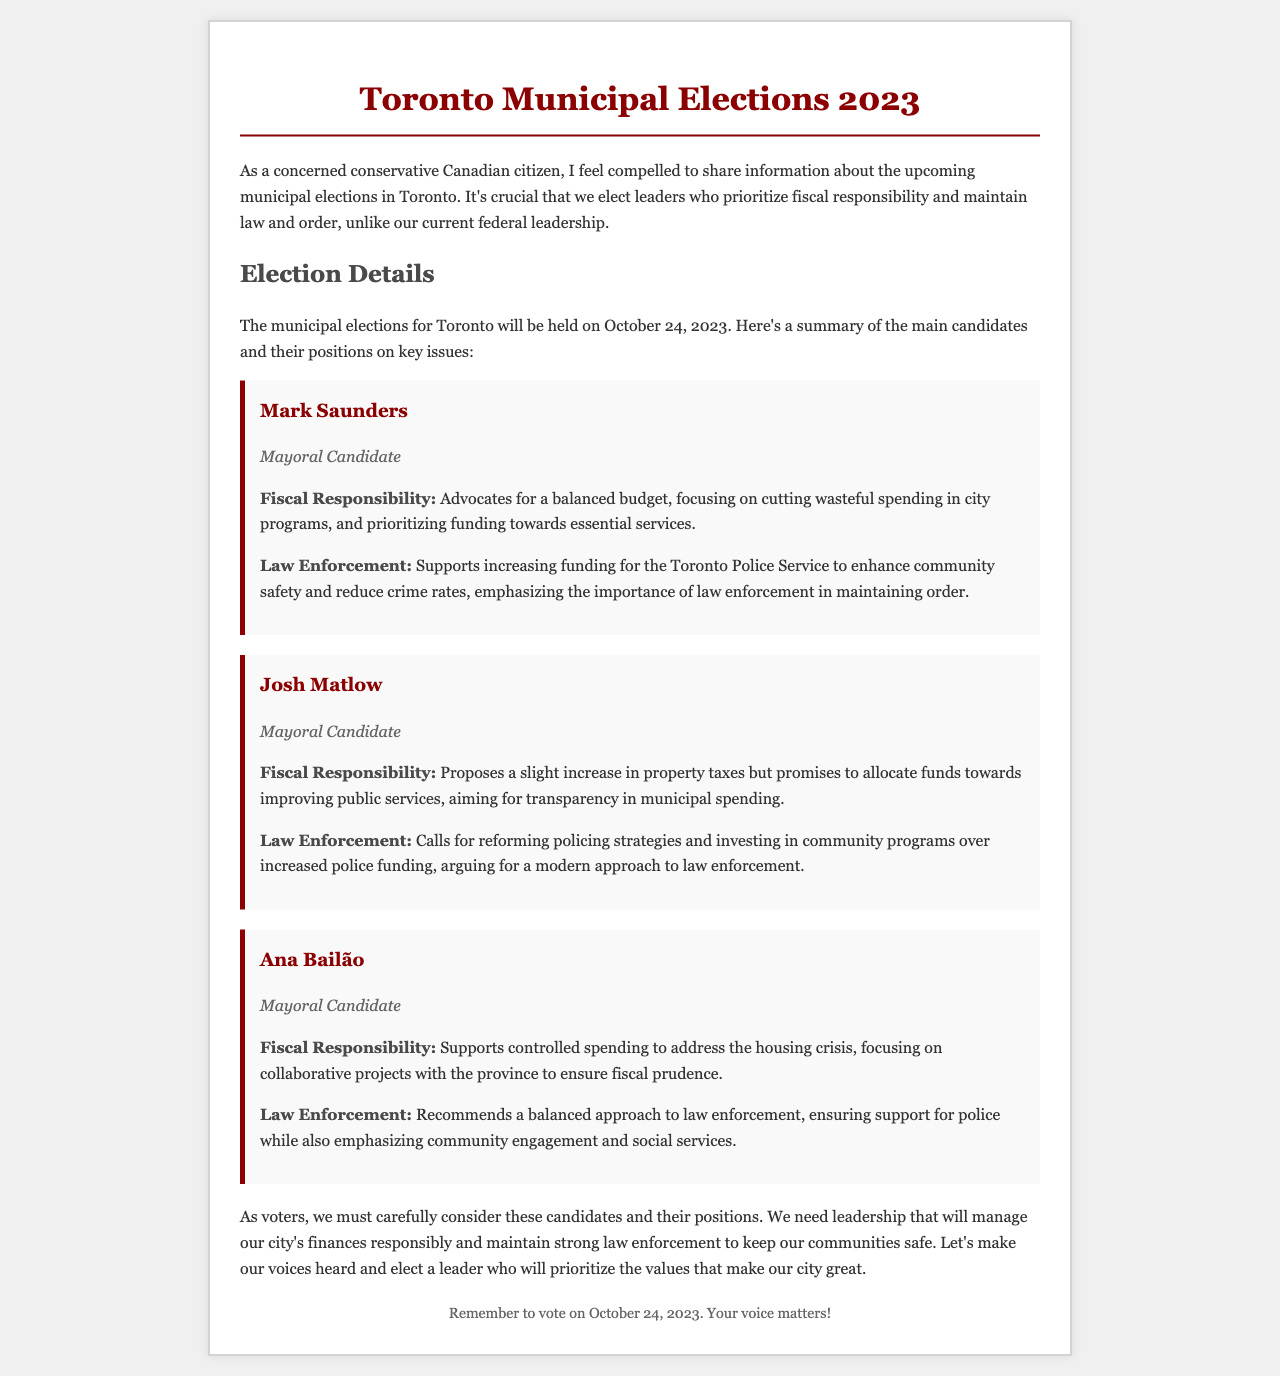What is the date of the municipal elections? The document states that the municipal elections will be held on October 24, 2023.
Answer: October 24, 2023 Who is the mayoral candidate advocating for a balanced budget? Mark Saunders is identified as the candidate advocating for a balanced budget in the document.
Answer: Mark Saunders What fiscal position does Josh Matlow propose? The document mentions that Josh Matlow proposes a slight increase in property taxes.
Answer: Slight increase in property taxes What law enforcement approach does Ana Bailão recommend? Ana Bailão recommends a balanced approach to law enforcement according to the document.
Answer: Balanced approach Which candidate supports increasing funding for the Toronto Police Service? The document indicates that Mark Saunders supports increasing funding for the Toronto Police Service.
Answer: Mark Saunders What is stated about Josh Matlow's strategy on law enforcement? Josh Matlow's strategy emphasizes reforming policing strategies and investing in community programs.
Answer: Reforming policing strategies How does the document describe the approach to fiscal responsibility of Ana Bailão? Ana Bailão's fiscal responsibility approach involves controlled spending to address the housing crisis.
Answer: Controlled spending What is the emphasis of Mark Saunders' law enforcement position? His position emphasizes the importance of law enforcement in maintaining order.
Answer: Importance of law enforcement Which mayoral candidate is associated with investing in community programs? The document associates investing in community programs with Josh Matlow.
Answer: Josh Matlow 